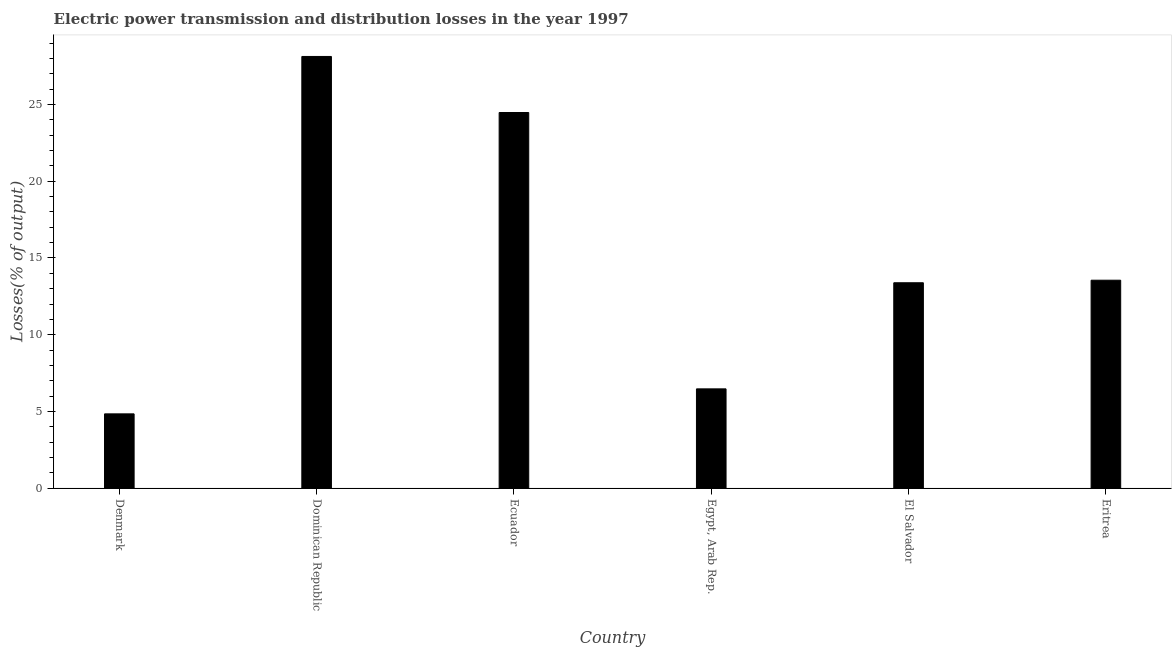What is the title of the graph?
Your response must be concise. Electric power transmission and distribution losses in the year 1997. What is the label or title of the X-axis?
Keep it short and to the point. Country. What is the label or title of the Y-axis?
Keep it short and to the point. Losses(% of output). What is the electric power transmission and distribution losses in Eritrea?
Provide a succinct answer. 13.55. Across all countries, what is the maximum electric power transmission and distribution losses?
Keep it short and to the point. 28.14. Across all countries, what is the minimum electric power transmission and distribution losses?
Provide a succinct answer. 4.84. In which country was the electric power transmission and distribution losses maximum?
Provide a succinct answer. Dominican Republic. In which country was the electric power transmission and distribution losses minimum?
Ensure brevity in your answer.  Denmark. What is the sum of the electric power transmission and distribution losses?
Make the answer very short. 90.86. What is the difference between the electric power transmission and distribution losses in Denmark and Egypt, Arab Rep.?
Your answer should be very brief. -1.63. What is the average electric power transmission and distribution losses per country?
Keep it short and to the point. 15.14. What is the median electric power transmission and distribution losses?
Provide a short and direct response. 13.47. What is the ratio of the electric power transmission and distribution losses in Dominican Republic to that in Egypt, Arab Rep.?
Give a very brief answer. 4.35. Is the difference between the electric power transmission and distribution losses in Dominican Republic and El Salvador greater than the difference between any two countries?
Your answer should be very brief. No. What is the difference between the highest and the second highest electric power transmission and distribution losses?
Provide a short and direct response. 3.65. What is the difference between the highest and the lowest electric power transmission and distribution losses?
Keep it short and to the point. 23.3. Are all the bars in the graph horizontal?
Ensure brevity in your answer.  No. How many countries are there in the graph?
Give a very brief answer. 6. Are the values on the major ticks of Y-axis written in scientific E-notation?
Provide a succinct answer. No. What is the Losses(% of output) of Denmark?
Keep it short and to the point. 4.84. What is the Losses(% of output) of Dominican Republic?
Make the answer very short. 28.14. What is the Losses(% of output) in Ecuador?
Provide a short and direct response. 24.48. What is the Losses(% of output) in Egypt, Arab Rep.?
Your answer should be compact. 6.47. What is the Losses(% of output) of El Salvador?
Your answer should be compact. 13.39. What is the Losses(% of output) in Eritrea?
Offer a very short reply. 13.55. What is the difference between the Losses(% of output) in Denmark and Dominican Republic?
Provide a short and direct response. -23.3. What is the difference between the Losses(% of output) in Denmark and Ecuador?
Your answer should be compact. -19.65. What is the difference between the Losses(% of output) in Denmark and Egypt, Arab Rep.?
Provide a short and direct response. -1.63. What is the difference between the Losses(% of output) in Denmark and El Salvador?
Provide a short and direct response. -8.55. What is the difference between the Losses(% of output) in Denmark and Eritrea?
Ensure brevity in your answer.  -8.71. What is the difference between the Losses(% of output) in Dominican Republic and Ecuador?
Make the answer very short. 3.65. What is the difference between the Losses(% of output) in Dominican Republic and Egypt, Arab Rep.?
Your answer should be compact. 21.67. What is the difference between the Losses(% of output) in Dominican Republic and El Salvador?
Ensure brevity in your answer.  14.75. What is the difference between the Losses(% of output) in Dominican Republic and Eritrea?
Ensure brevity in your answer.  14.59. What is the difference between the Losses(% of output) in Ecuador and Egypt, Arab Rep.?
Your answer should be very brief. 18.02. What is the difference between the Losses(% of output) in Ecuador and El Salvador?
Keep it short and to the point. 11.1. What is the difference between the Losses(% of output) in Ecuador and Eritrea?
Give a very brief answer. 10.93. What is the difference between the Losses(% of output) in Egypt, Arab Rep. and El Salvador?
Your response must be concise. -6.92. What is the difference between the Losses(% of output) in Egypt, Arab Rep. and Eritrea?
Offer a very short reply. -7.08. What is the difference between the Losses(% of output) in El Salvador and Eritrea?
Provide a short and direct response. -0.17. What is the ratio of the Losses(% of output) in Denmark to that in Dominican Republic?
Ensure brevity in your answer.  0.17. What is the ratio of the Losses(% of output) in Denmark to that in Ecuador?
Ensure brevity in your answer.  0.2. What is the ratio of the Losses(% of output) in Denmark to that in Egypt, Arab Rep.?
Provide a short and direct response. 0.75. What is the ratio of the Losses(% of output) in Denmark to that in El Salvador?
Give a very brief answer. 0.36. What is the ratio of the Losses(% of output) in Denmark to that in Eritrea?
Your response must be concise. 0.36. What is the ratio of the Losses(% of output) in Dominican Republic to that in Ecuador?
Your response must be concise. 1.15. What is the ratio of the Losses(% of output) in Dominican Republic to that in Egypt, Arab Rep.?
Keep it short and to the point. 4.35. What is the ratio of the Losses(% of output) in Dominican Republic to that in El Salvador?
Your response must be concise. 2.1. What is the ratio of the Losses(% of output) in Dominican Republic to that in Eritrea?
Keep it short and to the point. 2.08. What is the ratio of the Losses(% of output) in Ecuador to that in Egypt, Arab Rep.?
Offer a very short reply. 3.79. What is the ratio of the Losses(% of output) in Ecuador to that in El Salvador?
Your response must be concise. 1.83. What is the ratio of the Losses(% of output) in Ecuador to that in Eritrea?
Keep it short and to the point. 1.81. What is the ratio of the Losses(% of output) in Egypt, Arab Rep. to that in El Salvador?
Your response must be concise. 0.48. What is the ratio of the Losses(% of output) in Egypt, Arab Rep. to that in Eritrea?
Your answer should be compact. 0.48. 